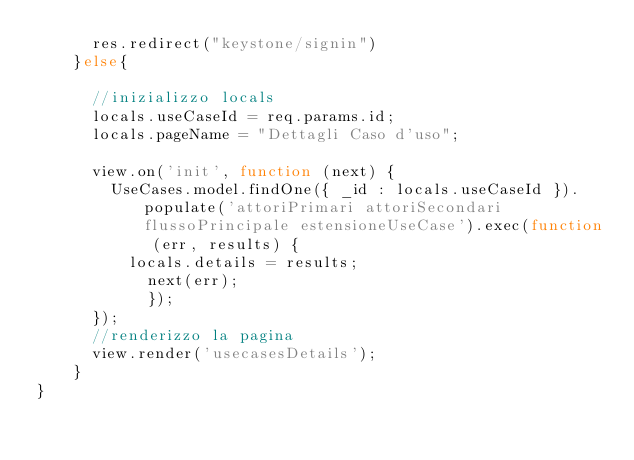Convert code to text. <code><loc_0><loc_0><loc_500><loc_500><_JavaScript_>      res.redirect("keystone/signin")
    }else{
      
      //inizializzo locals
      locals.useCaseId = req.params.id;
      locals.pageName = "Dettagli Caso d'uso";

      view.on('init', function (next) {
        UseCases.model.findOne({ _id : locals.useCaseId }).populate('attoriPrimari attoriSecondari flussoPrincipale estensioneUseCase').exec(function (err, results) {
          locals.details = results;
      		next(err);
  			});
      });
      //renderizzo la pagina
      view.render('usecasesDetails');
    }
}
</code> 